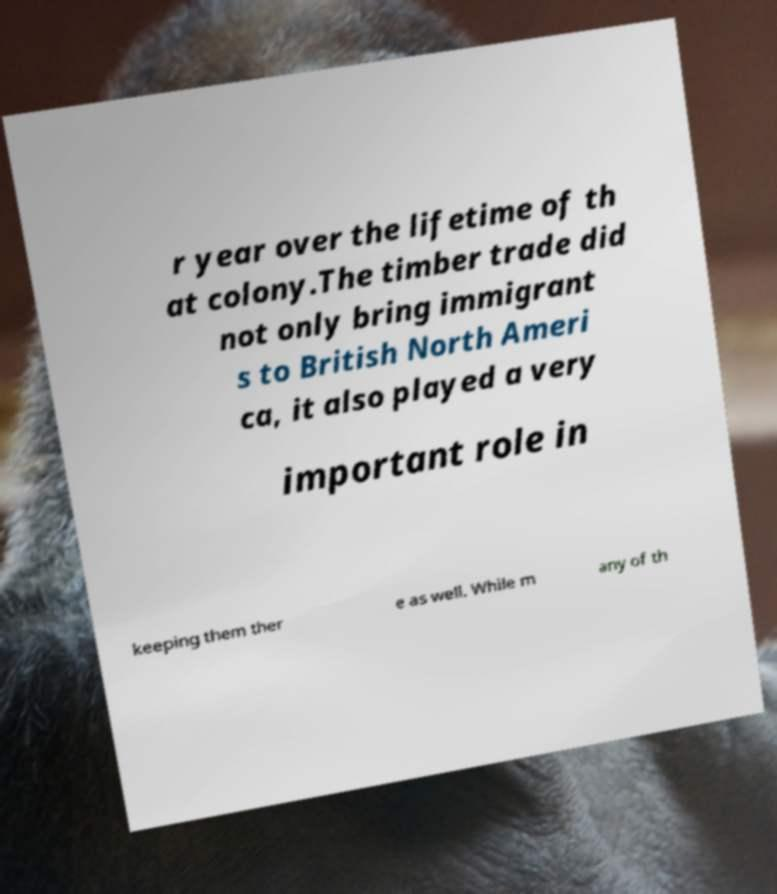For documentation purposes, I need the text within this image transcribed. Could you provide that? r year over the lifetime of th at colony.The timber trade did not only bring immigrant s to British North Ameri ca, it also played a very important role in keeping them ther e as well. While m any of th 